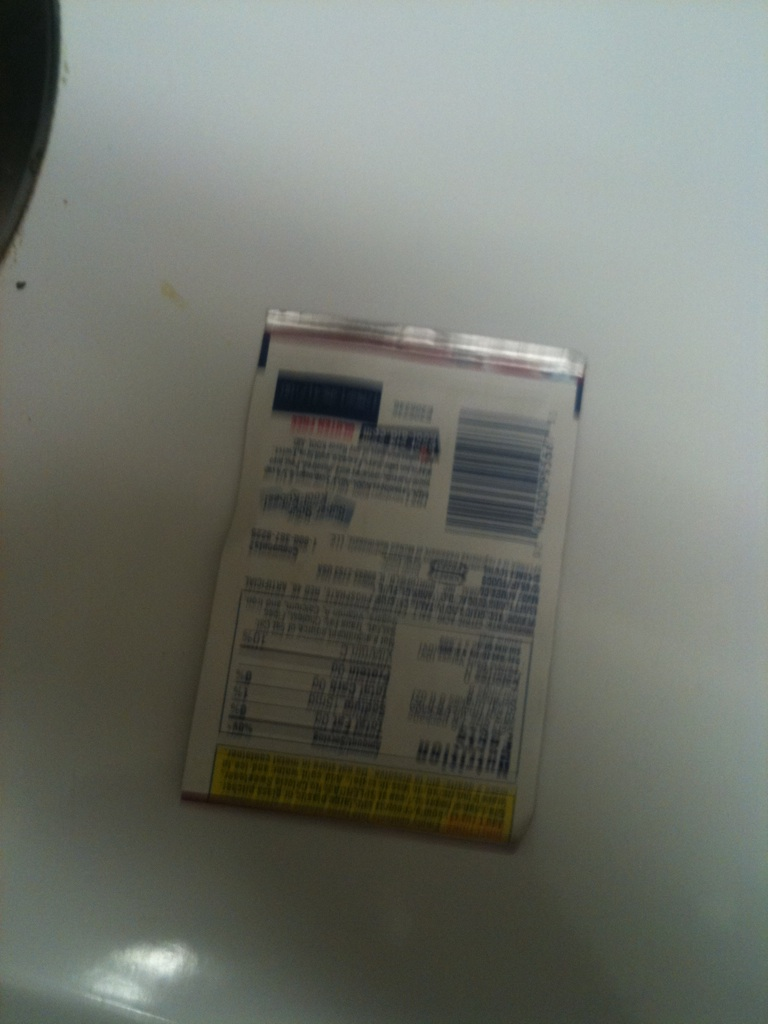Can you describe the nutritional information provided on this package? The nutritional information seems to be printed at the back of the package, though the text is not clear from this image. Generally, this section includes details about serving size, calories, fat, carbohydrates, protein, vitamins, and minerals. Please provide a clearer image for more specific information. 